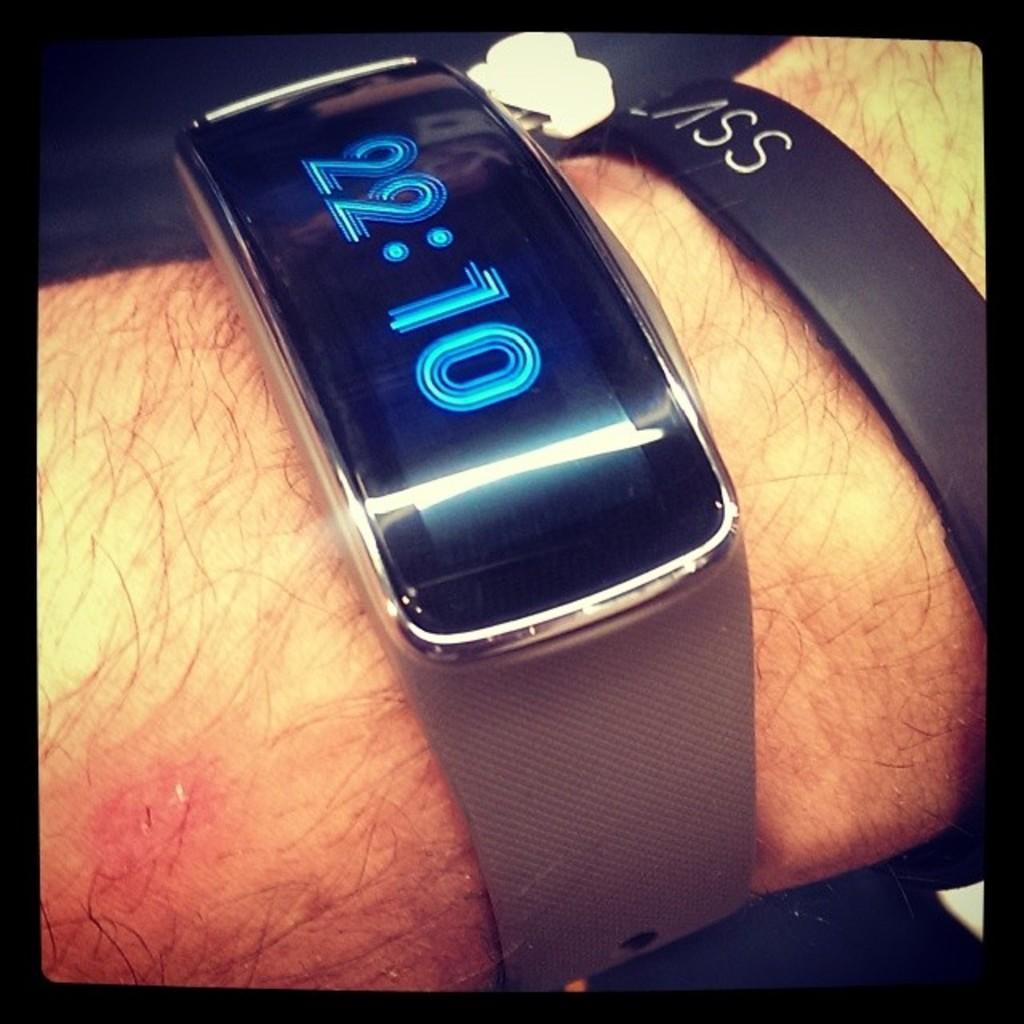How would you summarize this image in a sentence or two? In this image we can see some person's hand with the digital watch and also the band. The image has black color borders. 